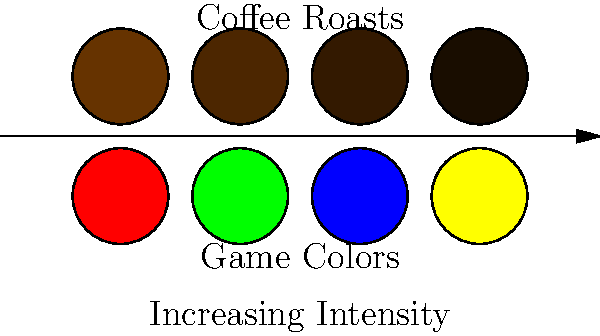In the color-matching challenge, which board game color scheme would be most appropriate to pair with the darkest coffee roast for a visually cohesive experience? To answer this question, we need to follow these steps:

1. Identify the darkest coffee roast:
   The coffee roasts are arranged from light to dark, left to right. The darkest roast is the rightmost circle in the top row.

2. Analyze the board game color schemes:
   The game colors are arranged in the bottom row, also from left to right.

3. Consider color theory and visual cohesion:
   We want to pair the darkest coffee roast with a game color that complements it and creates a visually appealing combination. Dark roasts are often associated with deep, rich flavors and a bold experience.

4. Compare the options:
   - Red (leftmost): Bright and energetic, might clash with the dark roast.
   - Green (second from left): Represents freshness, but might not match the intensity of the dark roast.
   - Blue (third from left): Deep and calming, could complement the richness of dark roast.
   - Yellow (rightmost): Bright and cheerful, might contrast too strongly with the dark roast.

5. Choose the best match:
   The blue color scheme (third from left in the bottom row) would be the most appropriate to pair with the darkest coffee roast. Blue's depth and intensity can match the boldness of a dark roast, creating a visually cohesive and sophisticated experience.
Answer: Blue 